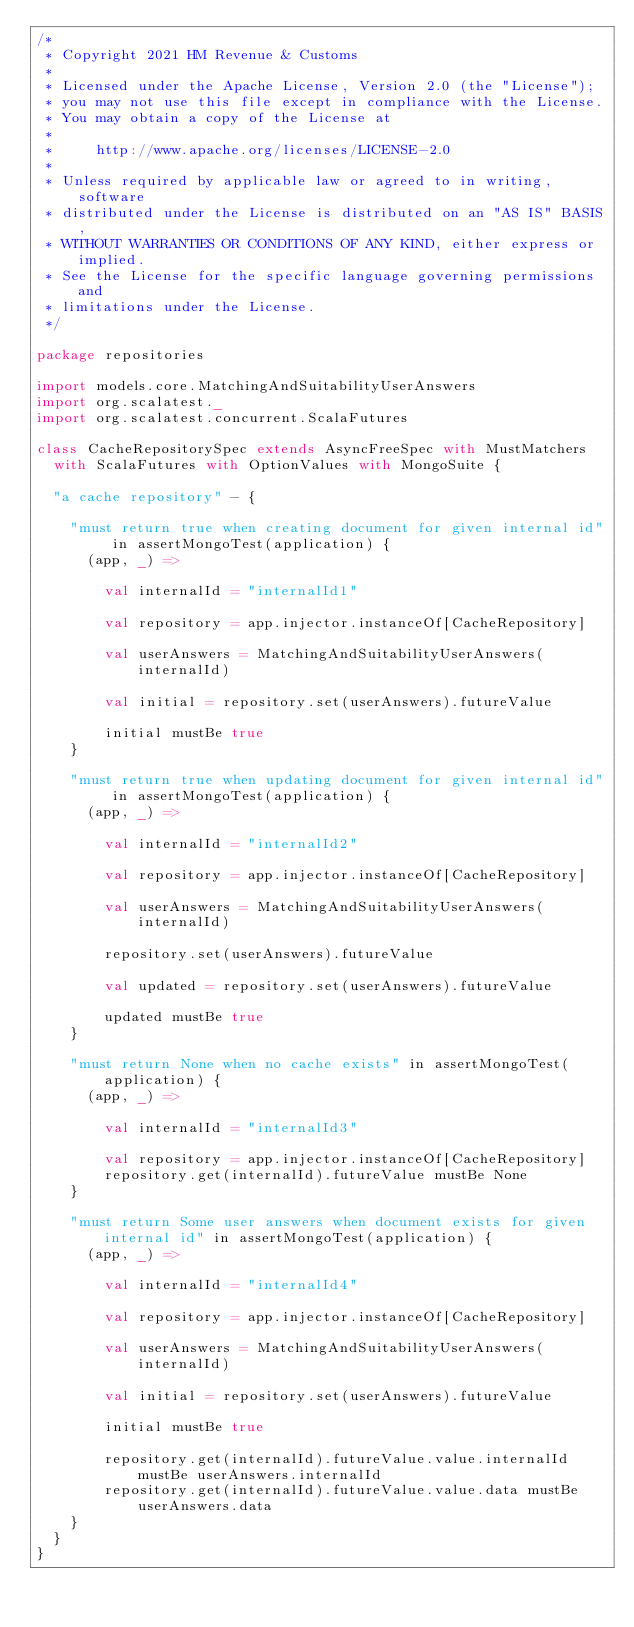<code> <loc_0><loc_0><loc_500><loc_500><_Scala_>/*
 * Copyright 2021 HM Revenue & Customs
 *
 * Licensed under the Apache License, Version 2.0 (the "License");
 * you may not use this file except in compliance with the License.
 * You may obtain a copy of the License at
 *
 *     http://www.apache.org/licenses/LICENSE-2.0
 *
 * Unless required by applicable law or agreed to in writing, software
 * distributed under the License is distributed on an "AS IS" BASIS,
 * WITHOUT WARRANTIES OR CONDITIONS OF ANY KIND, either express or implied.
 * See the License for the specific language governing permissions and
 * limitations under the License.
 */

package repositories

import models.core.MatchingAndSuitabilityUserAnswers
import org.scalatest._
import org.scalatest.concurrent.ScalaFutures

class CacheRepositorySpec extends AsyncFreeSpec with MustMatchers
  with ScalaFutures with OptionValues with MongoSuite {

  "a cache repository" - {

    "must return true when creating document for given internal id" in assertMongoTest(application) {
      (app, _) =>

        val internalId = "internalId1"

        val repository = app.injector.instanceOf[CacheRepository]

        val userAnswers = MatchingAndSuitabilityUserAnswers(internalId)

        val initial = repository.set(userAnswers).futureValue

        initial mustBe true
    }

    "must return true when updating document for given internal id" in assertMongoTest(application) {
      (app, _) =>

        val internalId = "internalId2"

        val repository = app.injector.instanceOf[CacheRepository]

        val userAnswers = MatchingAndSuitabilityUserAnswers(internalId)

        repository.set(userAnswers).futureValue

        val updated = repository.set(userAnswers).futureValue

        updated mustBe true
    }

    "must return None when no cache exists" in assertMongoTest(application) {
      (app, _) =>

        val internalId = "internalId3"

        val repository = app.injector.instanceOf[CacheRepository]
        repository.get(internalId).futureValue mustBe None
    }

    "must return Some user answers when document exists for given internal id" in assertMongoTest(application) {
      (app, _) =>

        val internalId = "internalId4"

        val repository = app.injector.instanceOf[CacheRepository]

        val userAnswers = MatchingAndSuitabilityUserAnswers(internalId)

        val initial = repository.set(userAnswers).futureValue

        initial mustBe true

        repository.get(internalId).futureValue.value.internalId mustBe userAnswers.internalId
        repository.get(internalId).futureValue.value.data mustBe userAnswers.data
    }
  }
}
</code> 